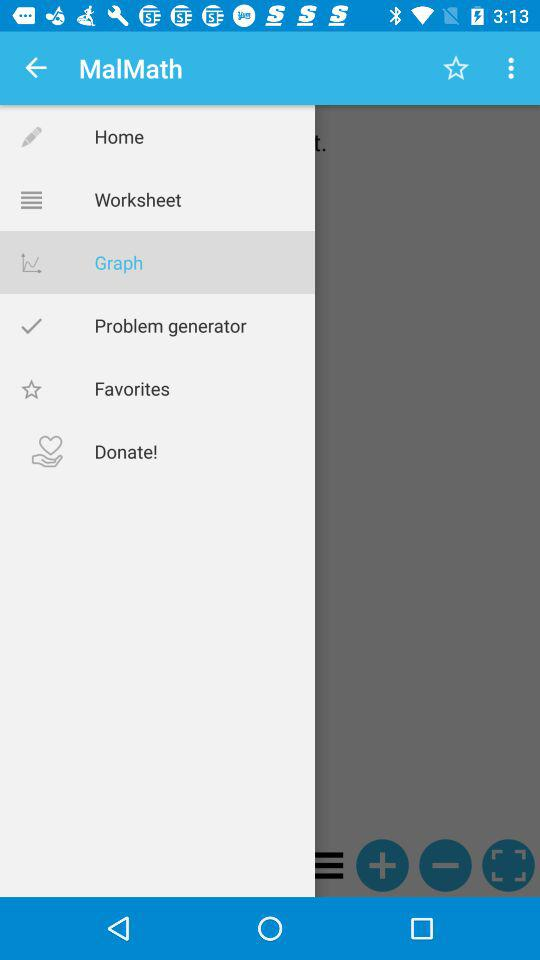Which item is selected in the menu? The selected item is "Graph". 